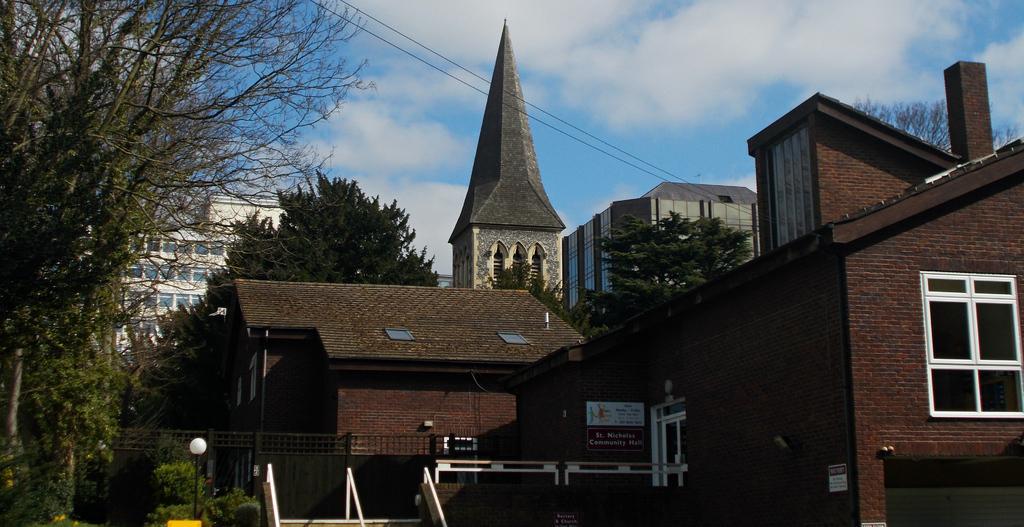Can you describe this image briefly? In this image we can see buildings with windows. Also there is a name board. And there are railings. And there is a light pole. Near to the buildings there are trees. In the background there is sky with clouds. 